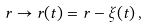<formula> <loc_0><loc_0><loc_500><loc_500>r \to r ( t ) = r - \xi ( t ) \, ,</formula> 